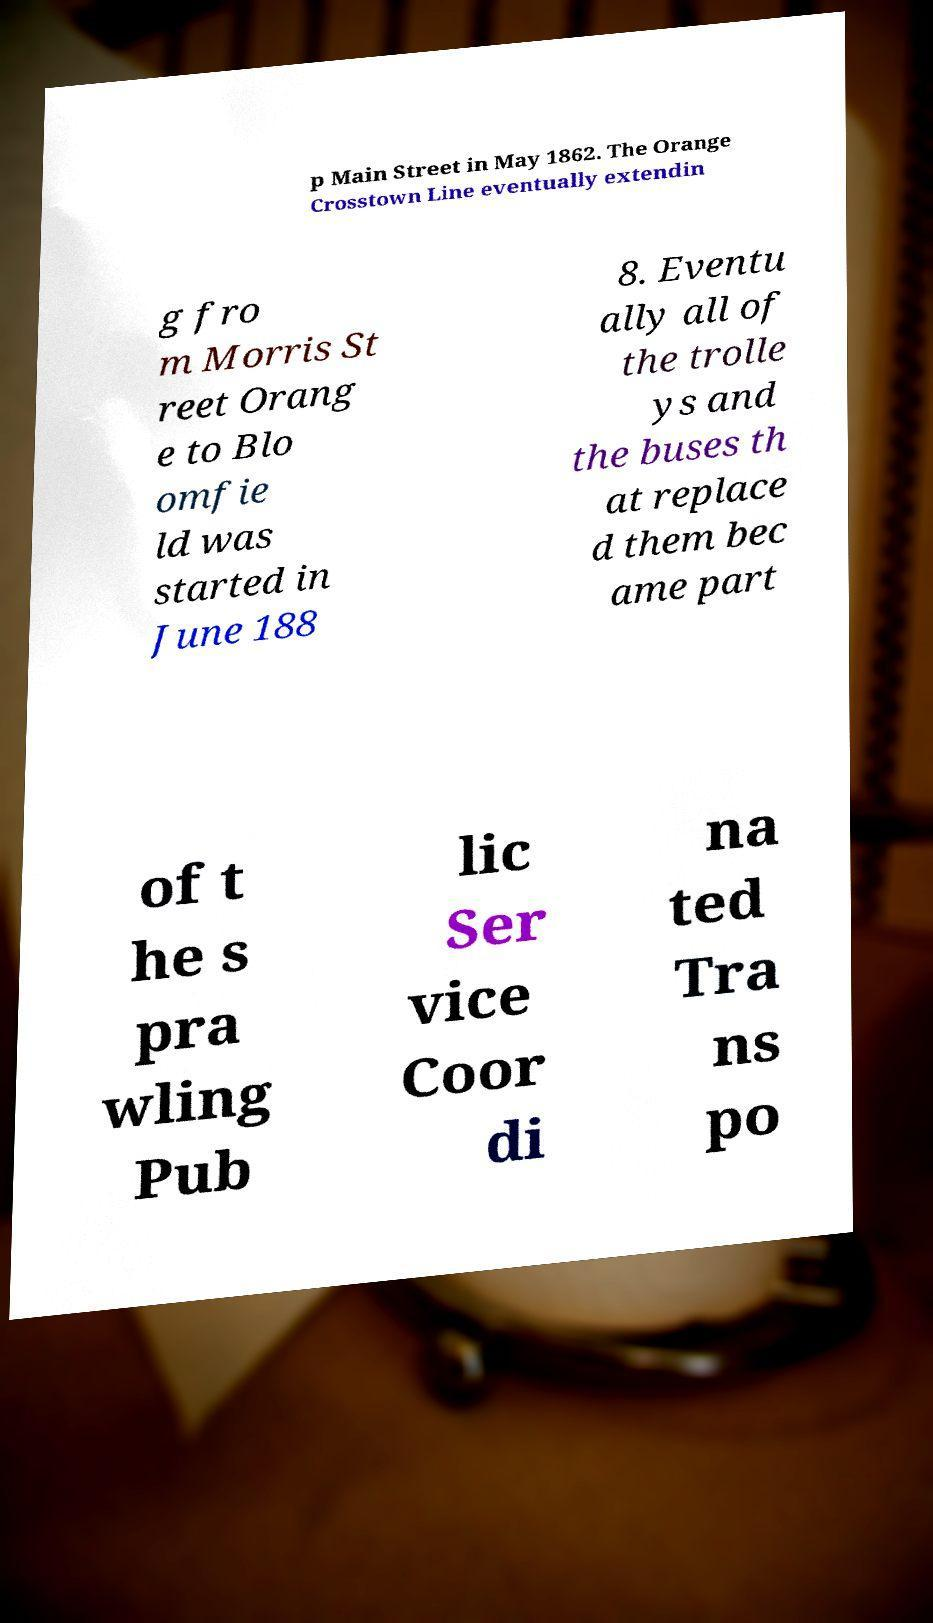There's text embedded in this image that I need extracted. Can you transcribe it verbatim? p Main Street in May 1862. The Orange Crosstown Line eventually extendin g fro m Morris St reet Orang e to Blo omfie ld was started in June 188 8. Eventu ally all of the trolle ys and the buses th at replace d them bec ame part of t he s pra wling Pub lic Ser vice Coor di na ted Tra ns po 